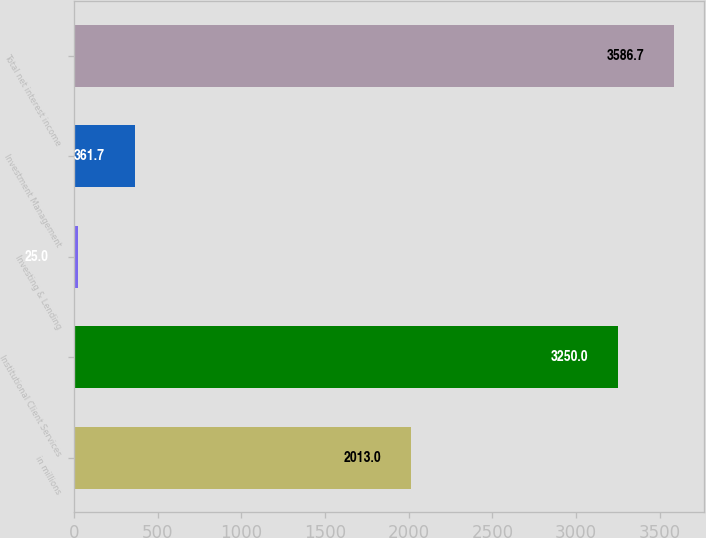Convert chart. <chart><loc_0><loc_0><loc_500><loc_500><bar_chart><fcel>in millions<fcel>Institutional Client Services<fcel>Investing & Lending<fcel>Investment Management<fcel>Total net interest income<nl><fcel>2013<fcel>3250<fcel>25<fcel>361.7<fcel>3586.7<nl></chart> 